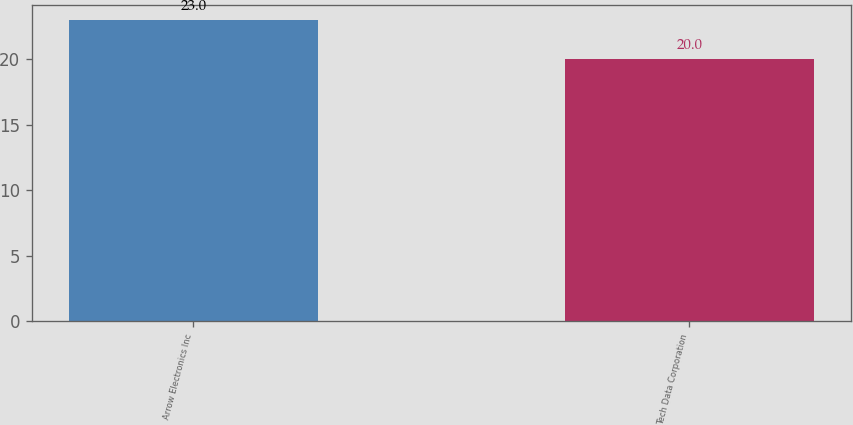<chart> <loc_0><loc_0><loc_500><loc_500><bar_chart><fcel>Arrow Electronics Inc<fcel>Tech Data Corporation<nl><fcel>23<fcel>20<nl></chart> 